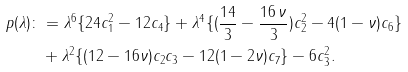Convert formula to latex. <formula><loc_0><loc_0><loc_500><loc_500>p ( \lambda ) \colon & = \lambda ^ { 6 } \{ 2 4 c _ { 1 } ^ { 2 } - 1 2 c _ { 4 } \} + \lambda ^ { 4 } \{ ( \frac { 1 4 } { 3 } - \frac { 1 6 \, \nu } { 3 } ) c _ { 2 } ^ { 2 } - 4 ( 1 - \nu ) c _ { 6 } \} \\ & + \lambda ^ { 2 } \{ ( 1 2 - 1 6 \nu ) c _ { 2 } c _ { 3 } - 1 2 ( 1 - 2 \nu ) c _ { 7 } \} - 6 c _ { 3 } ^ { 2 } .</formula> 